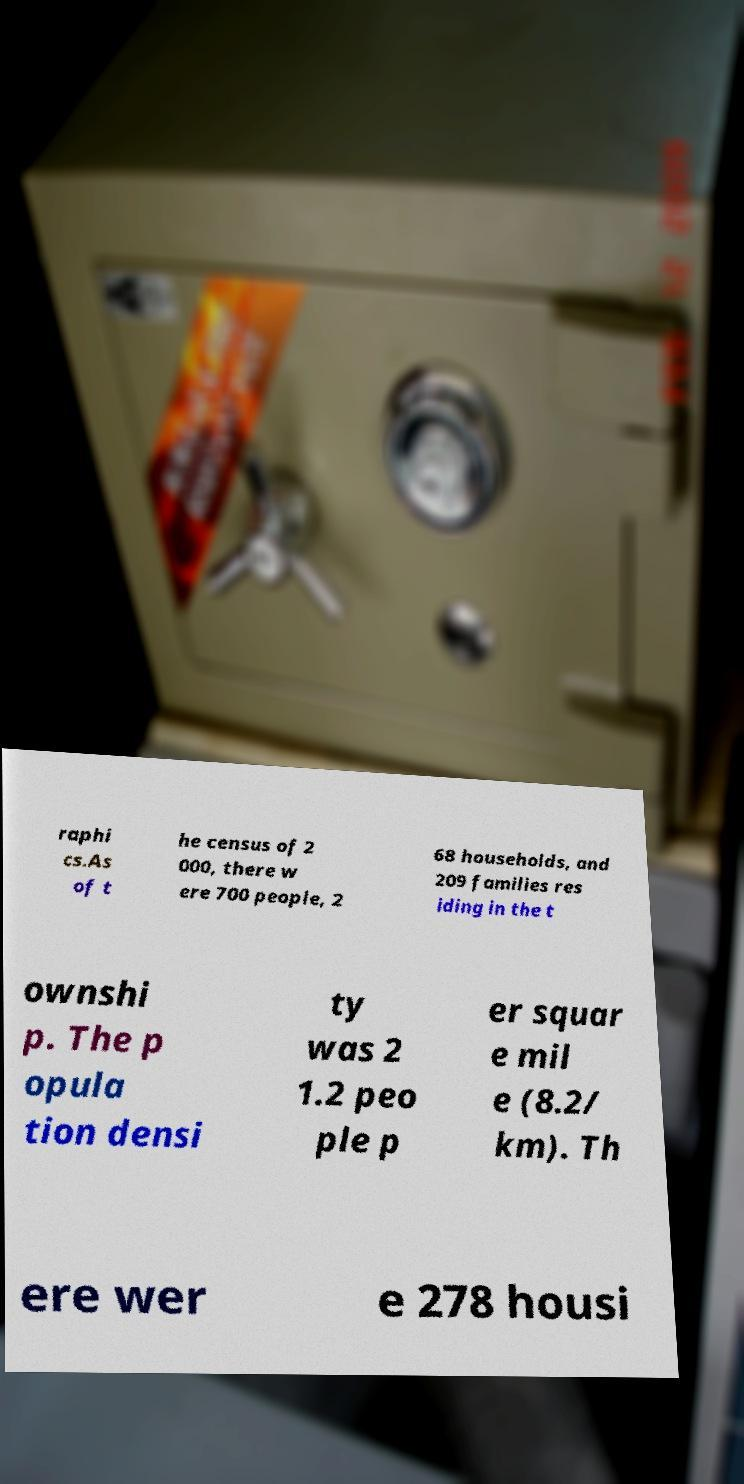For documentation purposes, I need the text within this image transcribed. Could you provide that? raphi cs.As of t he census of 2 000, there w ere 700 people, 2 68 households, and 209 families res iding in the t ownshi p. The p opula tion densi ty was 2 1.2 peo ple p er squar e mil e (8.2/ km). Th ere wer e 278 housi 